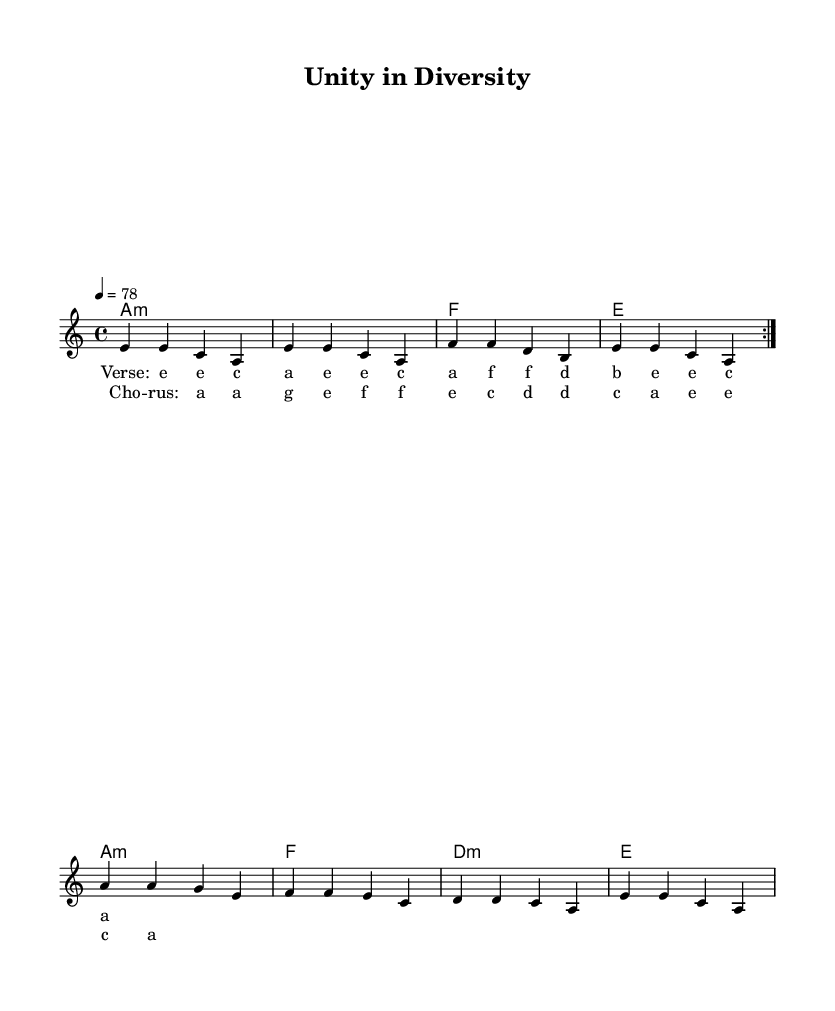What is the key signature of this music? The key signature is A minor, which is identified by the absence of sharps and flats. A minor is the relative minor of C major, which also has no accidentals.
Answer: A minor What is the time signature of this music? The time signature is 4/4, which is indicated at the beginning of the sheet music. This means there are four beats per measure and a quarter note receives one beat.
Answer: 4/4 What is the tempo marking in this music? The tempo marking indicates a speed of 78 beats per minute, which is noted at the start of the score. This speed is typical for reggae, allowing for a relaxed and laid-back feel.
Answer: 78 How many measures are in the melody section? There are 8 measures in the melody section as indicated by the repeated volta and the music lines presented. Each line represents two measures, and two lines are shown before the break.
Answer: 8 What is the chord progression for the chorus? The chord progression for the chorus follows the pattern of A minor, A minor, G major, F major, which is derived from the harmonic structure provided in the chord mode section in relation to the lyrics.
Answer: A minor, A minor, G, F What unique characteristics of reggae music can be observed in this piece? The piece showcases traditional reggae features such as the offbeat strumming, laid-back tempo, and a focus on social themes within the lyrics, which aligns with the idea of politically conscious reggae.
Answer: Offbeat strumming and laid-back tempo Which instrument does the melody line represent in this score? The melody line in this score represents the lead voice, as indicated by the label "Voice = 'lead'". This suggests it is meant to be played by a singer or lead instrument in a reggae arrangement.
Answer: Lead voice 